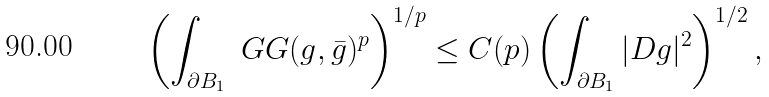<formula> <loc_0><loc_0><loc_500><loc_500>\left ( \int _ { \partial B _ { 1 } } \ G G ( g , \bar { g } ) ^ { p } \right ) ^ { 1 / p } \leq C ( p ) \left ( \int _ { \partial B _ { 1 } } | D g | ^ { 2 } \right ) ^ { 1 / 2 } ,</formula> 